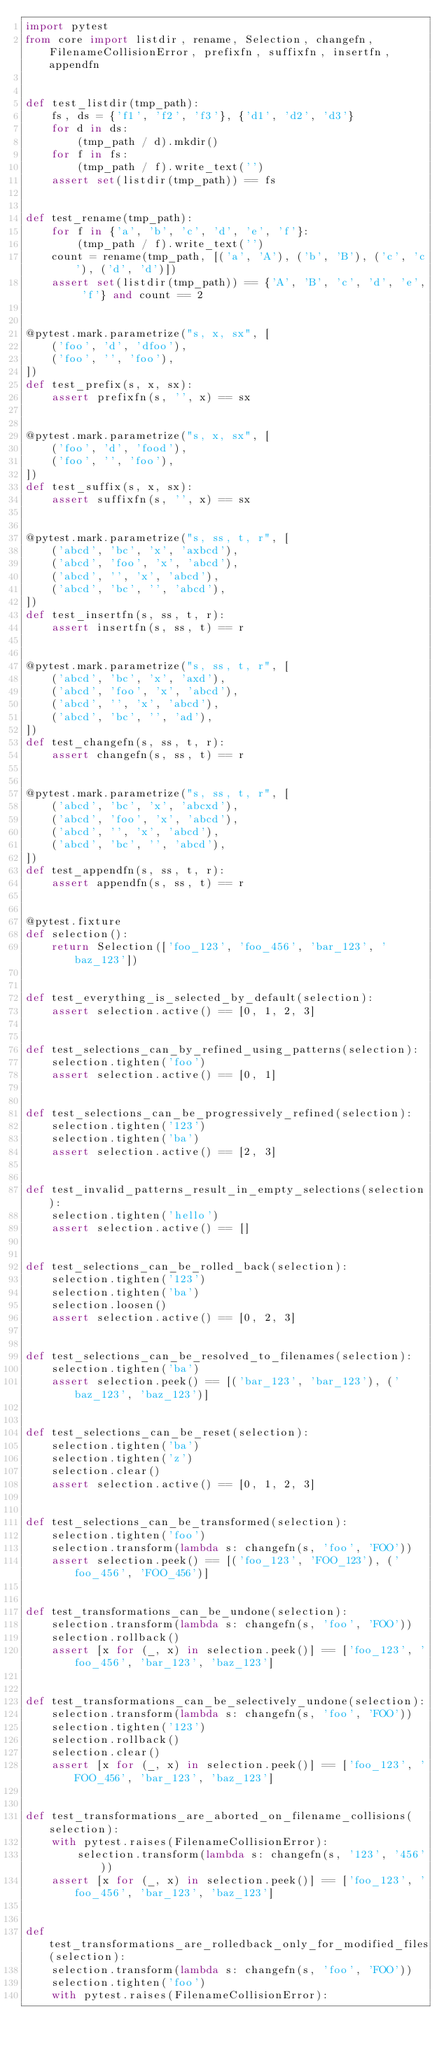Convert code to text. <code><loc_0><loc_0><loc_500><loc_500><_Python_>import pytest
from core import listdir, rename, Selection, changefn, FilenameCollisionError, prefixfn, suffixfn, insertfn, appendfn


def test_listdir(tmp_path):
    fs, ds = {'f1', 'f2', 'f3'}, {'d1', 'd2', 'd3'}
    for d in ds:
        (tmp_path / d).mkdir()
    for f in fs:
        (tmp_path / f).write_text('')
    assert set(listdir(tmp_path)) == fs


def test_rename(tmp_path):
    for f in {'a', 'b', 'c', 'd', 'e', 'f'}:
        (tmp_path / f).write_text('')
    count = rename(tmp_path, [('a', 'A'), ('b', 'B'), ('c', 'c'), ('d', 'd')])
    assert set(listdir(tmp_path)) == {'A', 'B', 'c', 'd', 'e', 'f'} and count == 2


@pytest.mark.parametrize("s, x, sx", [
    ('foo', 'd', 'dfoo'),
    ('foo', '', 'foo'),
])
def test_prefix(s, x, sx):
    assert prefixfn(s, '', x) == sx


@pytest.mark.parametrize("s, x, sx", [
    ('foo', 'd', 'food'),
    ('foo', '', 'foo'),
])
def test_suffix(s, x, sx):
    assert suffixfn(s, '', x) == sx


@pytest.mark.parametrize("s, ss, t, r", [
    ('abcd', 'bc', 'x', 'axbcd'),
    ('abcd', 'foo', 'x', 'abcd'),
    ('abcd', '', 'x', 'abcd'),
    ('abcd', 'bc', '', 'abcd'),
])
def test_insertfn(s, ss, t, r):
    assert insertfn(s, ss, t) == r


@pytest.mark.parametrize("s, ss, t, r", [
    ('abcd', 'bc', 'x', 'axd'),
    ('abcd', 'foo', 'x', 'abcd'),
    ('abcd', '', 'x', 'abcd'),
    ('abcd', 'bc', '', 'ad'),
])
def test_changefn(s, ss, t, r):
    assert changefn(s, ss, t) == r


@pytest.mark.parametrize("s, ss, t, r", [
    ('abcd', 'bc', 'x', 'abcxd'),
    ('abcd', 'foo', 'x', 'abcd'),
    ('abcd', '', 'x', 'abcd'),
    ('abcd', 'bc', '', 'abcd'),
])
def test_appendfn(s, ss, t, r):
    assert appendfn(s, ss, t) == r


@pytest.fixture
def selection():
    return Selection(['foo_123', 'foo_456', 'bar_123', 'baz_123'])


def test_everything_is_selected_by_default(selection):
    assert selection.active() == [0, 1, 2, 3]


def test_selections_can_by_refined_using_patterns(selection):
    selection.tighten('foo')
    assert selection.active() == [0, 1]


def test_selections_can_be_progressively_refined(selection):
    selection.tighten('123')
    selection.tighten('ba')
    assert selection.active() == [2, 3]


def test_invalid_patterns_result_in_empty_selections(selection):
    selection.tighten('hello')
    assert selection.active() == []


def test_selections_can_be_rolled_back(selection):
    selection.tighten('123')
    selection.tighten('ba')
    selection.loosen()
    assert selection.active() == [0, 2, 3]


def test_selections_can_be_resolved_to_filenames(selection):
    selection.tighten('ba')
    assert selection.peek() == [('bar_123', 'bar_123'), ('baz_123', 'baz_123')]


def test_selections_can_be_reset(selection):
    selection.tighten('ba')
    selection.tighten('z')
    selection.clear()
    assert selection.active() == [0, 1, 2, 3]


def test_selections_can_be_transformed(selection):
    selection.tighten('foo')
    selection.transform(lambda s: changefn(s, 'foo', 'FOO'))
    assert selection.peek() == [('foo_123', 'FOO_123'), ('foo_456', 'FOO_456')]


def test_transformations_can_be_undone(selection):
    selection.transform(lambda s: changefn(s, 'foo', 'FOO'))
    selection.rollback()
    assert [x for (_, x) in selection.peek()] == ['foo_123', 'foo_456', 'bar_123', 'baz_123']


def test_transformations_can_be_selectively_undone(selection):
    selection.transform(lambda s: changefn(s, 'foo', 'FOO'))
    selection.tighten('123')
    selection.rollback()
    selection.clear()
    assert [x for (_, x) in selection.peek()] == ['foo_123', 'FOO_456', 'bar_123', 'baz_123']


def test_transformations_are_aborted_on_filename_collisions(selection):
    with pytest.raises(FilenameCollisionError):
        selection.transform(lambda s: changefn(s, '123', '456'))
    assert [x for (_, x) in selection.peek()] == ['foo_123', 'foo_456', 'bar_123', 'baz_123']


def test_transformations_are_rolledback_only_for_modified_files(selection):
    selection.transform(lambda s: changefn(s, 'foo', 'FOO'))
    selection.tighten('foo')
    with pytest.raises(FilenameCollisionError):</code> 